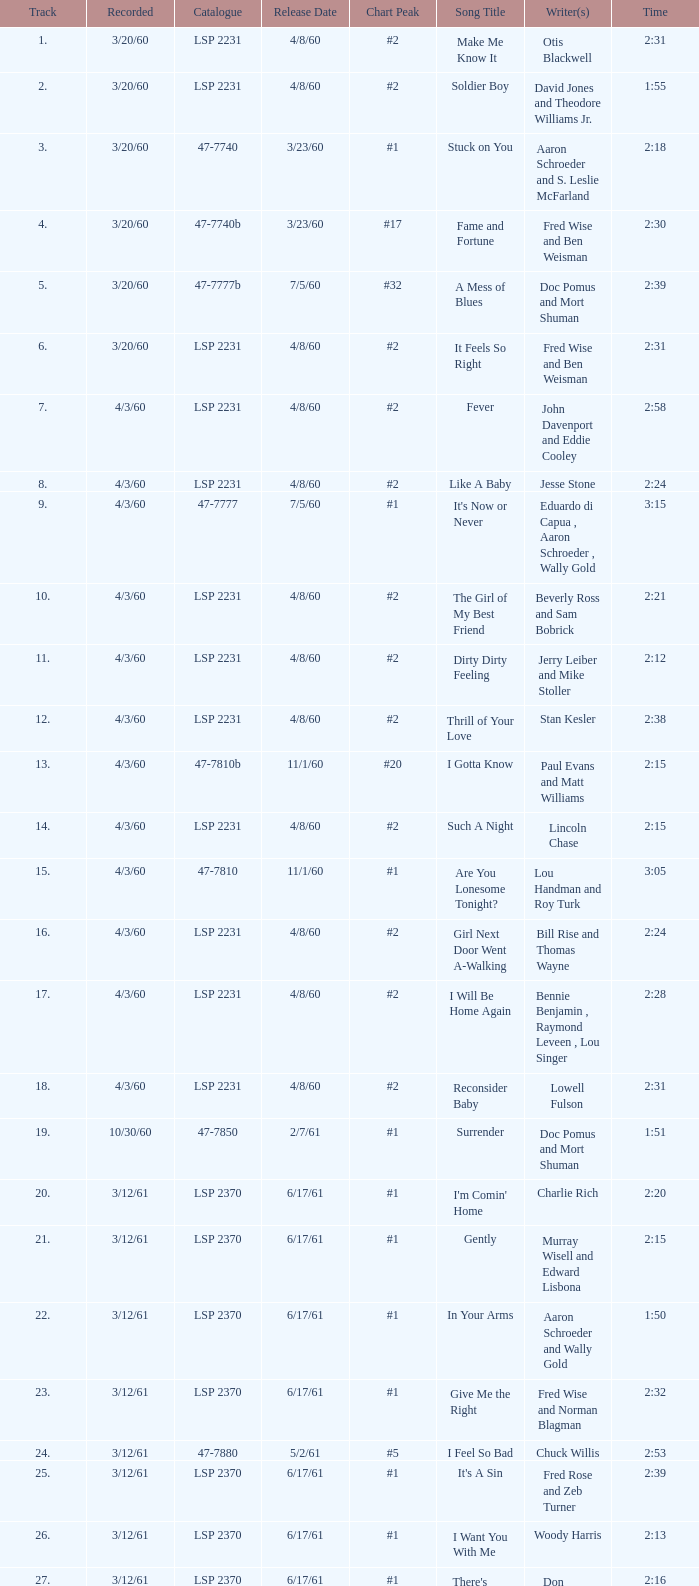What catalogue is the song It's Now or Never? 47-7777. 